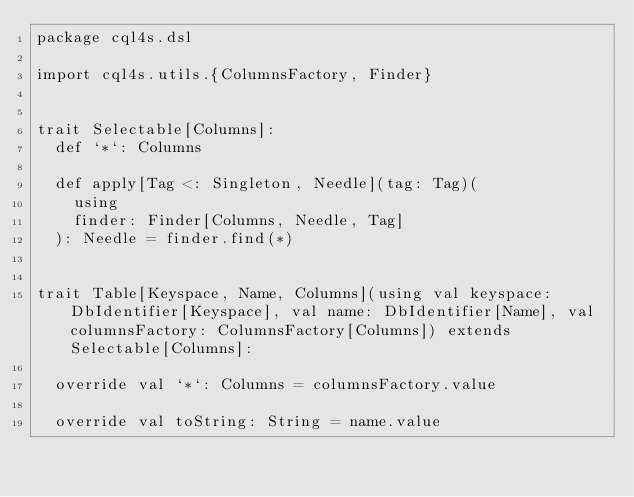<code> <loc_0><loc_0><loc_500><loc_500><_Scala_>package cql4s.dsl

import cql4s.utils.{ColumnsFactory, Finder}


trait Selectable[Columns]:
  def `*`: Columns

  def apply[Tag <: Singleton, Needle](tag: Tag)(
    using
    finder: Finder[Columns, Needle, Tag]
  ): Needle = finder.find(*)


trait Table[Keyspace, Name, Columns](using val keyspace: DbIdentifier[Keyspace], val name: DbIdentifier[Name], val columnsFactory: ColumnsFactory[Columns]) extends Selectable[Columns]:

  override val `*`: Columns = columnsFactory.value

  override val toString: String = name.value
</code> 